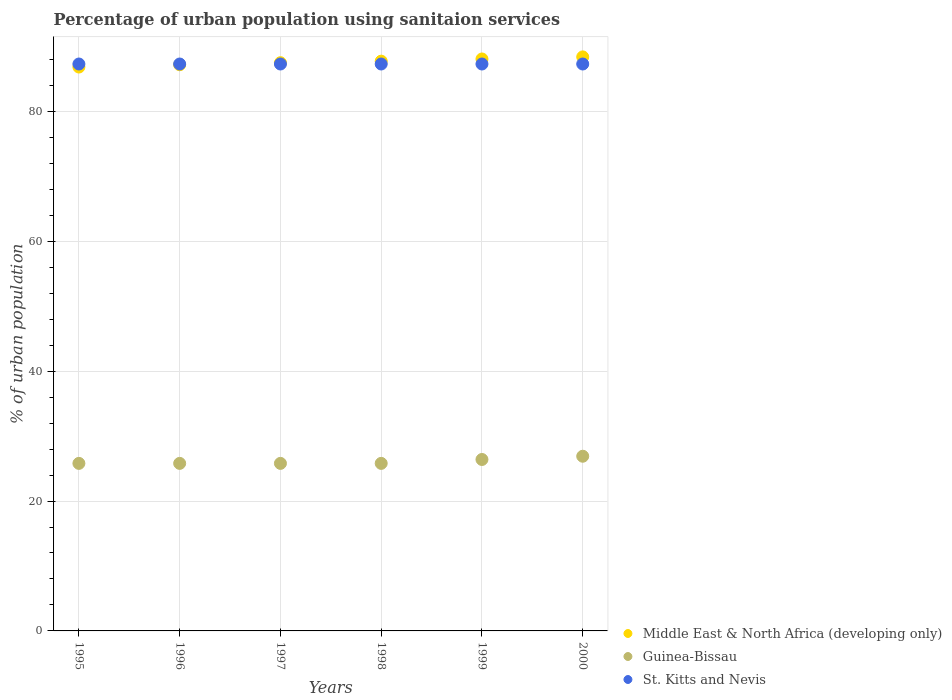Is the number of dotlines equal to the number of legend labels?
Your answer should be compact. Yes. What is the percentage of urban population using sanitaion services in Guinea-Bissau in 1999?
Give a very brief answer. 26.4. Across all years, what is the maximum percentage of urban population using sanitaion services in Guinea-Bissau?
Provide a short and direct response. 26.9. Across all years, what is the minimum percentage of urban population using sanitaion services in Guinea-Bissau?
Your answer should be very brief. 25.8. In which year was the percentage of urban population using sanitaion services in St. Kitts and Nevis minimum?
Ensure brevity in your answer.  1995. What is the total percentage of urban population using sanitaion services in Middle East & North Africa (developing only) in the graph?
Provide a succinct answer. 525.73. What is the difference between the percentage of urban population using sanitaion services in St. Kitts and Nevis in 1997 and that in 1998?
Your response must be concise. 0. What is the difference between the percentage of urban population using sanitaion services in Guinea-Bissau in 1998 and the percentage of urban population using sanitaion services in Middle East & North Africa (developing only) in 1995?
Make the answer very short. -61.03. What is the average percentage of urban population using sanitaion services in St. Kitts and Nevis per year?
Ensure brevity in your answer.  87.3. In the year 1995, what is the difference between the percentage of urban population using sanitaion services in Middle East & North Africa (developing only) and percentage of urban population using sanitaion services in Guinea-Bissau?
Offer a terse response. 61.03. What is the ratio of the percentage of urban population using sanitaion services in Middle East & North Africa (developing only) in 1998 to that in 1999?
Your response must be concise. 1. Is the percentage of urban population using sanitaion services in Guinea-Bissau in 1995 less than that in 2000?
Make the answer very short. Yes. In how many years, is the percentage of urban population using sanitaion services in St. Kitts and Nevis greater than the average percentage of urban population using sanitaion services in St. Kitts and Nevis taken over all years?
Keep it short and to the point. 0. Is the sum of the percentage of urban population using sanitaion services in Guinea-Bissau in 1999 and 2000 greater than the maximum percentage of urban population using sanitaion services in St. Kitts and Nevis across all years?
Your answer should be very brief. No. Is it the case that in every year, the sum of the percentage of urban population using sanitaion services in Middle East & North Africa (developing only) and percentage of urban population using sanitaion services in St. Kitts and Nevis  is greater than the percentage of urban population using sanitaion services in Guinea-Bissau?
Make the answer very short. Yes. How many years are there in the graph?
Your answer should be very brief. 6. What is the difference between two consecutive major ticks on the Y-axis?
Ensure brevity in your answer.  20. Where does the legend appear in the graph?
Provide a short and direct response. Bottom right. How many legend labels are there?
Offer a terse response. 3. How are the legend labels stacked?
Your answer should be compact. Vertical. What is the title of the graph?
Offer a terse response. Percentage of urban population using sanitaion services. What is the label or title of the X-axis?
Give a very brief answer. Years. What is the label or title of the Y-axis?
Provide a short and direct response. % of urban population. What is the % of urban population of Middle East & North Africa (developing only) in 1995?
Your response must be concise. 86.83. What is the % of urban population in Guinea-Bissau in 1995?
Give a very brief answer. 25.8. What is the % of urban population of St. Kitts and Nevis in 1995?
Your answer should be compact. 87.3. What is the % of urban population of Middle East & North Africa (developing only) in 1996?
Give a very brief answer. 87.19. What is the % of urban population in Guinea-Bissau in 1996?
Give a very brief answer. 25.8. What is the % of urban population in St. Kitts and Nevis in 1996?
Your response must be concise. 87.3. What is the % of urban population in Middle East & North Africa (developing only) in 1997?
Keep it short and to the point. 87.5. What is the % of urban population in Guinea-Bissau in 1997?
Provide a succinct answer. 25.8. What is the % of urban population of St. Kitts and Nevis in 1997?
Provide a short and direct response. 87.3. What is the % of urban population in Middle East & North Africa (developing only) in 1998?
Your answer should be compact. 87.74. What is the % of urban population in Guinea-Bissau in 1998?
Your answer should be compact. 25.8. What is the % of urban population in St. Kitts and Nevis in 1998?
Offer a very short reply. 87.3. What is the % of urban population in Middle East & North Africa (developing only) in 1999?
Your answer should be compact. 88.08. What is the % of urban population of Guinea-Bissau in 1999?
Give a very brief answer. 26.4. What is the % of urban population in St. Kitts and Nevis in 1999?
Make the answer very short. 87.3. What is the % of urban population of Middle East & North Africa (developing only) in 2000?
Keep it short and to the point. 88.39. What is the % of urban population of Guinea-Bissau in 2000?
Ensure brevity in your answer.  26.9. What is the % of urban population in St. Kitts and Nevis in 2000?
Provide a succinct answer. 87.3. Across all years, what is the maximum % of urban population in Middle East & North Africa (developing only)?
Make the answer very short. 88.39. Across all years, what is the maximum % of urban population in Guinea-Bissau?
Give a very brief answer. 26.9. Across all years, what is the maximum % of urban population of St. Kitts and Nevis?
Your response must be concise. 87.3. Across all years, what is the minimum % of urban population of Middle East & North Africa (developing only)?
Ensure brevity in your answer.  86.83. Across all years, what is the minimum % of urban population of Guinea-Bissau?
Your answer should be compact. 25.8. Across all years, what is the minimum % of urban population of St. Kitts and Nevis?
Give a very brief answer. 87.3. What is the total % of urban population in Middle East & North Africa (developing only) in the graph?
Provide a short and direct response. 525.73. What is the total % of urban population of Guinea-Bissau in the graph?
Ensure brevity in your answer.  156.5. What is the total % of urban population in St. Kitts and Nevis in the graph?
Offer a very short reply. 523.8. What is the difference between the % of urban population of Middle East & North Africa (developing only) in 1995 and that in 1996?
Keep it short and to the point. -0.35. What is the difference between the % of urban population of Guinea-Bissau in 1995 and that in 1996?
Keep it short and to the point. 0. What is the difference between the % of urban population of Middle East & North Africa (developing only) in 1995 and that in 1997?
Ensure brevity in your answer.  -0.67. What is the difference between the % of urban population of Middle East & North Africa (developing only) in 1995 and that in 1998?
Offer a very short reply. -0.91. What is the difference between the % of urban population of Guinea-Bissau in 1995 and that in 1998?
Give a very brief answer. 0. What is the difference between the % of urban population in Middle East & North Africa (developing only) in 1995 and that in 1999?
Make the answer very short. -1.24. What is the difference between the % of urban population of St. Kitts and Nevis in 1995 and that in 1999?
Your answer should be very brief. 0. What is the difference between the % of urban population of Middle East & North Africa (developing only) in 1995 and that in 2000?
Your answer should be compact. -1.56. What is the difference between the % of urban population in Guinea-Bissau in 1995 and that in 2000?
Provide a succinct answer. -1.1. What is the difference between the % of urban population of Middle East & North Africa (developing only) in 1996 and that in 1997?
Make the answer very short. -0.31. What is the difference between the % of urban population of Guinea-Bissau in 1996 and that in 1997?
Your answer should be compact. 0. What is the difference between the % of urban population of St. Kitts and Nevis in 1996 and that in 1997?
Provide a succinct answer. 0. What is the difference between the % of urban population of Middle East & North Africa (developing only) in 1996 and that in 1998?
Your answer should be compact. -0.55. What is the difference between the % of urban population in Guinea-Bissau in 1996 and that in 1998?
Your answer should be compact. 0. What is the difference between the % of urban population of Middle East & North Africa (developing only) in 1996 and that in 1999?
Your response must be concise. -0.89. What is the difference between the % of urban population of Guinea-Bissau in 1996 and that in 1999?
Ensure brevity in your answer.  -0.6. What is the difference between the % of urban population in Middle East & North Africa (developing only) in 1996 and that in 2000?
Provide a short and direct response. -1.21. What is the difference between the % of urban population in St. Kitts and Nevis in 1996 and that in 2000?
Make the answer very short. 0. What is the difference between the % of urban population in Middle East & North Africa (developing only) in 1997 and that in 1998?
Your answer should be very brief. -0.24. What is the difference between the % of urban population in Guinea-Bissau in 1997 and that in 1998?
Make the answer very short. 0. What is the difference between the % of urban population in St. Kitts and Nevis in 1997 and that in 1998?
Give a very brief answer. 0. What is the difference between the % of urban population of Middle East & North Africa (developing only) in 1997 and that in 1999?
Offer a very short reply. -0.57. What is the difference between the % of urban population of Middle East & North Africa (developing only) in 1997 and that in 2000?
Your response must be concise. -0.89. What is the difference between the % of urban population of Middle East & North Africa (developing only) in 1998 and that in 1999?
Offer a terse response. -0.34. What is the difference between the % of urban population in Guinea-Bissau in 1998 and that in 1999?
Your answer should be compact. -0.6. What is the difference between the % of urban population of Middle East & North Africa (developing only) in 1998 and that in 2000?
Offer a very short reply. -0.66. What is the difference between the % of urban population in Guinea-Bissau in 1998 and that in 2000?
Offer a terse response. -1.1. What is the difference between the % of urban population in St. Kitts and Nevis in 1998 and that in 2000?
Give a very brief answer. 0. What is the difference between the % of urban population in Middle East & North Africa (developing only) in 1999 and that in 2000?
Your response must be concise. -0.32. What is the difference between the % of urban population in Guinea-Bissau in 1999 and that in 2000?
Make the answer very short. -0.5. What is the difference between the % of urban population of St. Kitts and Nevis in 1999 and that in 2000?
Offer a very short reply. 0. What is the difference between the % of urban population in Middle East & North Africa (developing only) in 1995 and the % of urban population in Guinea-Bissau in 1996?
Give a very brief answer. 61.03. What is the difference between the % of urban population in Middle East & North Africa (developing only) in 1995 and the % of urban population in St. Kitts and Nevis in 1996?
Your response must be concise. -0.47. What is the difference between the % of urban population in Guinea-Bissau in 1995 and the % of urban population in St. Kitts and Nevis in 1996?
Provide a short and direct response. -61.5. What is the difference between the % of urban population of Middle East & North Africa (developing only) in 1995 and the % of urban population of Guinea-Bissau in 1997?
Your response must be concise. 61.03. What is the difference between the % of urban population in Middle East & North Africa (developing only) in 1995 and the % of urban population in St. Kitts and Nevis in 1997?
Ensure brevity in your answer.  -0.47. What is the difference between the % of urban population of Guinea-Bissau in 1995 and the % of urban population of St. Kitts and Nevis in 1997?
Offer a very short reply. -61.5. What is the difference between the % of urban population of Middle East & North Africa (developing only) in 1995 and the % of urban population of Guinea-Bissau in 1998?
Keep it short and to the point. 61.03. What is the difference between the % of urban population of Middle East & North Africa (developing only) in 1995 and the % of urban population of St. Kitts and Nevis in 1998?
Offer a terse response. -0.47. What is the difference between the % of urban population of Guinea-Bissau in 1995 and the % of urban population of St. Kitts and Nevis in 1998?
Ensure brevity in your answer.  -61.5. What is the difference between the % of urban population of Middle East & North Africa (developing only) in 1995 and the % of urban population of Guinea-Bissau in 1999?
Offer a terse response. 60.43. What is the difference between the % of urban population in Middle East & North Africa (developing only) in 1995 and the % of urban population in St. Kitts and Nevis in 1999?
Give a very brief answer. -0.47. What is the difference between the % of urban population in Guinea-Bissau in 1995 and the % of urban population in St. Kitts and Nevis in 1999?
Keep it short and to the point. -61.5. What is the difference between the % of urban population in Middle East & North Africa (developing only) in 1995 and the % of urban population in Guinea-Bissau in 2000?
Keep it short and to the point. 59.93. What is the difference between the % of urban population of Middle East & North Africa (developing only) in 1995 and the % of urban population of St. Kitts and Nevis in 2000?
Your answer should be compact. -0.47. What is the difference between the % of urban population in Guinea-Bissau in 1995 and the % of urban population in St. Kitts and Nevis in 2000?
Keep it short and to the point. -61.5. What is the difference between the % of urban population of Middle East & North Africa (developing only) in 1996 and the % of urban population of Guinea-Bissau in 1997?
Give a very brief answer. 61.39. What is the difference between the % of urban population in Middle East & North Africa (developing only) in 1996 and the % of urban population in St. Kitts and Nevis in 1997?
Your answer should be compact. -0.11. What is the difference between the % of urban population of Guinea-Bissau in 1996 and the % of urban population of St. Kitts and Nevis in 1997?
Offer a terse response. -61.5. What is the difference between the % of urban population of Middle East & North Africa (developing only) in 1996 and the % of urban population of Guinea-Bissau in 1998?
Give a very brief answer. 61.39. What is the difference between the % of urban population in Middle East & North Africa (developing only) in 1996 and the % of urban population in St. Kitts and Nevis in 1998?
Keep it short and to the point. -0.11. What is the difference between the % of urban population of Guinea-Bissau in 1996 and the % of urban population of St. Kitts and Nevis in 1998?
Provide a short and direct response. -61.5. What is the difference between the % of urban population of Middle East & North Africa (developing only) in 1996 and the % of urban population of Guinea-Bissau in 1999?
Offer a very short reply. 60.79. What is the difference between the % of urban population of Middle East & North Africa (developing only) in 1996 and the % of urban population of St. Kitts and Nevis in 1999?
Offer a very short reply. -0.11. What is the difference between the % of urban population of Guinea-Bissau in 1996 and the % of urban population of St. Kitts and Nevis in 1999?
Provide a short and direct response. -61.5. What is the difference between the % of urban population in Middle East & North Africa (developing only) in 1996 and the % of urban population in Guinea-Bissau in 2000?
Provide a succinct answer. 60.29. What is the difference between the % of urban population in Middle East & North Africa (developing only) in 1996 and the % of urban population in St. Kitts and Nevis in 2000?
Your answer should be compact. -0.11. What is the difference between the % of urban population of Guinea-Bissau in 1996 and the % of urban population of St. Kitts and Nevis in 2000?
Your answer should be compact. -61.5. What is the difference between the % of urban population of Middle East & North Africa (developing only) in 1997 and the % of urban population of Guinea-Bissau in 1998?
Provide a short and direct response. 61.7. What is the difference between the % of urban population of Middle East & North Africa (developing only) in 1997 and the % of urban population of St. Kitts and Nevis in 1998?
Offer a very short reply. 0.2. What is the difference between the % of urban population of Guinea-Bissau in 1997 and the % of urban population of St. Kitts and Nevis in 1998?
Your answer should be compact. -61.5. What is the difference between the % of urban population in Middle East & North Africa (developing only) in 1997 and the % of urban population in Guinea-Bissau in 1999?
Provide a succinct answer. 61.1. What is the difference between the % of urban population in Middle East & North Africa (developing only) in 1997 and the % of urban population in St. Kitts and Nevis in 1999?
Provide a succinct answer. 0.2. What is the difference between the % of urban population of Guinea-Bissau in 1997 and the % of urban population of St. Kitts and Nevis in 1999?
Provide a succinct answer. -61.5. What is the difference between the % of urban population of Middle East & North Africa (developing only) in 1997 and the % of urban population of Guinea-Bissau in 2000?
Provide a short and direct response. 60.6. What is the difference between the % of urban population of Middle East & North Africa (developing only) in 1997 and the % of urban population of St. Kitts and Nevis in 2000?
Give a very brief answer. 0.2. What is the difference between the % of urban population of Guinea-Bissau in 1997 and the % of urban population of St. Kitts and Nevis in 2000?
Provide a succinct answer. -61.5. What is the difference between the % of urban population in Middle East & North Africa (developing only) in 1998 and the % of urban population in Guinea-Bissau in 1999?
Keep it short and to the point. 61.34. What is the difference between the % of urban population of Middle East & North Africa (developing only) in 1998 and the % of urban population of St. Kitts and Nevis in 1999?
Offer a very short reply. 0.44. What is the difference between the % of urban population in Guinea-Bissau in 1998 and the % of urban population in St. Kitts and Nevis in 1999?
Provide a short and direct response. -61.5. What is the difference between the % of urban population of Middle East & North Africa (developing only) in 1998 and the % of urban population of Guinea-Bissau in 2000?
Provide a short and direct response. 60.84. What is the difference between the % of urban population of Middle East & North Africa (developing only) in 1998 and the % of urban population of St. Kitts and Nevis in 2000?
Provide a succinct answer. 0.44. What is the difference between the % of urban population of Guinea-Bissau in 1998 and the % of urban population of St. Kitts and Nevis in 2000?
Your answer should be compact. -61.5. What is the difference between the % of urban population of Middle East & North Africa (developing only) in 1999 and the % of urban population of Guinea-Bissau in 2000?
Your response must be concise. 61.18. What is the difference between the % of urban population of Middle East & North Africa (developing only) in 1999 and the % of urban population of St. Kitts and Nevis in 2000?
Provide a succinct answer. 0.78. What is the difference between the % of urban population in Guinea-Bissau in 1999 and the % of urban population in St. Kitts and Nevis in 2000?
Your response must be concise. -60.9. What is the average % of urban population in Middle East & North Africa (developing only) per year?
Give a very brief answer. 87.62. What is the average % of urban population of Guinea-Bissau per year?
Make the answer very short. 26.08. What is the average % of urban population in St. Kitts and Nevis per year?
Make the answer very short. 87.3. In the year 1995, what is the difference between the % of urban population of Middle East & North Africa (developing only) and % of urban population of Guinea-Bissau?
Your answer should be very brief. 61.03. In the year 1995, what is the difference between the % of urban population of Middle East & North Africa (developing only) and % of urban population of St. Kitts and Nevis?
Ensure brevity in your answer.  -0.47. In the year 1995, what is the difference between the % of urban population of Guinea-Bissau and % of urban population of St. Kitts and Nevis?
Provide a short and direct response. -61.5. In the year 1996, what is the difference between the % of urban population in Middle East & North Africa (developing only) and % of urban population in Guinea-Bissau?
Your response must be concise. 61.39. In the year 1996, what is the difference between the % of urban population of Middle East & North Africa (developing only) and % of urban population of St. Kitts and Nevis?
Keep it short and to the point. -0.11. In the year 1996, what is the difference between the % of urban population of Guinea-Bissau and % of urban population of St. Kitts and Nevis?
Make the answer very short. -61.5. In the year 1997, what is the difference between the % of urban population of Middle East & North Africa (developing only) and % of urban population of Guinea-Bissau?
Offer a terse response. 61.7. In the year 1997, what is the difference between the % of urban population in Middle East & North Africa (developing only) and % of urban population in St. Kitts and Nevis?
Keep it short and to the point. 0.2. In the year 1997, what is the difference between the % of urban population of Guinea-Bissau and % of urban population of St. Kitts and Nevis?
Ensure brevity in your answer.  -61.5. In the year 1998, what is the difference between the % of urban population of Middle East & North Africa (developing only) and % of urban population of Guinea-Bissau?
Keep it short and to the point. 61.94. In the year 1998, what is the difference between the % of urban population of Middle East & North Africa (developing only) and % of urban population of St. Kitts and Nevis?
Keep it short and to the point. 0.44. In the year 1998, what is the difference between the % of urban population of Guinea-Bissau and % of urban population of St. Kitts and Nevis?
Offer a terse response. -61.5. In the year 1999, what is the difference between the % of urban population in Middle East & North Africa (developing only) and % of urban population in Guinea-Bissau?
Provide a succinct answer. 61.68. In the year 1999, what is the difference between the % of urban population of Middle East & North Africa (developing only) and % of urban population of St. Kitts and Nevis?
Provide a short and direct response. 0.78. In the year 1999, what is the difference between the % of urban population in Guinea-Bissau and % of urban population in St. Kitts and Nevis?
Make the answer very short. -60.9. In the year 2000, what is the difference between the % of urban population of Middle East & North Africa (developing only) and % of urban population of Guinea-Bissau?
Provide a succinct answer. 61.49. In the year 2000, what is the difference between the % of urban population in Middle East & North Africa (developing only) and % of urban population in St. Kitts and Nevis?
Make the answer very short. 1.09. In the year 2000, what is the difference between the % of urban population in Guinea-Bissau and % of urban population in St. Kitts and Nevis?
Provide a short and direct response. -60.4. What is the ratio of the % of urban population in Middle East & North Africa (developing only) in 1995 to that in 1996?
Your answer should be compact. 1. What is the ratio of the % of urban population of Guinea-Bissau in 1995 to that in 1996?
Offer a very short reply. 1. What is the ratio of the % of urban population in St. Kitts and Nevis in 1995 to that in 1997?
Make the answer very short. 1. What is the ratio of the % of urban population of Guinea-Bissau in 1995 to that in 1998?
Offer a terse response. 1. What is the ratio of the % of urban population in Middle East & North Africa (developing only) in 1995 to that in 1999?
Give a very brief answer. 0.99. What is the ratio of the % of urban population of Guinea-Bissau in 1995 to that in 1999?
Your answer should be compact. 0.98. What is the ratio of the % of urban population of Middle East & North Africa (developing only) in 1995 to that in 2000?
Your answer should be very brief. 0.98. What is the ratio of the % of urban population in Guinea-Bissau in 1995 to that in 2000?
Ensure brevity in your answer.  0.96. What is the ratio of the % of urban population of Guinea-Bissau in 1996 to that in 1997?
Give a very brief answer. 1. What is the ratio of the % of urban population of St. Kitts and Nevis in 1996 to that in 1997?
Keep it short and to the point. 1. What is the ratio of the % of urban population of Middle East & North Africa (developing only) in 1996 to that in 1998?
Your response must be concise. 0.99. What is the ratio of the % of urban population of Guinea-Bissau in 1996 to that in 1998?
Give a very brief answer. 1. What is the ratio of the % of urban population of Middle East & North Africa (developing only) in 1996 to that in 1999?
Provide a short and direct response. 0.99. What is the ratio of the % of urban population in Guinea-Bissau in 1996 to that in 1999?
Provide a succinct answer. 0.98. What is the ratio of the % of urban population of St. Kitts and Nevis in 1996 to that in 1999?
Provide a short and direct response. 1. What is the ratio of the % of urban population of Middle East & North Africa (developing only) in 1996 to that in 2000?
Make the answer very short. 0.99. What is the ratio of the % of urban population of Guinea-Bissau in 1996 to that in 2000?
Make the answer very short. 0.96. What is the ratio of the % of urban population of St. Kitts and Nevis in 1997 to that in 1998?
Offer a very short reply. 1. What is the ratio of the % of urban population of Guinea-Bissau in 1997 to that in 1999?
Your answer should be compact. 0.98. What is the ratio of the % of urban population in St. Kitts and Nevis in 1997 to that in 1999?
Keep it short and to the point. 1. What is the ratio of the % of urban population in Guinea-Bissau in 1997 to that in 2000?
Your response must be concise. 0.96. What is the ratio of the % of urban population of Middle East & North Africa (developing only) in 1998 to that in 1999?
Make the answer very short. 1. What is the ratio of the % of urban population in Guinea-Bissau in 1998 to that in 1999?
Offer a terse response. 0.98. What is the ratio of the % of urban population in St. Kitts and Nevis in 1998 to that in 1999?
Your answer should be compact. 1. What is the ratio of the % of urban population in Middle East & North Africa (developing only) in 1998 to that in 2000?
Make the answer very short. 0.99. What is the ratio of the % of urban population in Guinea-Bissau in 1998 to that in 2000?
Your answer should be compact. 0.96. What is the ratio of the % of urban population of Middle East & North Africa (developing only) in 1999 to that in 2000?
Your answer should be compact. 1. What is the ratio of the % of urban population in Guinea-Bissau in 1999 to that in 2000?
Your answer should be very brief. 0.98. What is the difference between the highest and the second highest % of urban population of Middle East & North Africa (developing only)?
Keep it short and to the point. 0.32. What is the difference between the highest and the second highest % of urban population of Guinea-Bissau?
Keep it short and to the point. 0.5. What is the difference between the highest and the second highest % of urban population in St. Kitts and Nevis?
Offer a very short reply. 0. What is the difference between the highest and the lowest % of urban population in Middle East & North Africa (developing only)?
Keep it short and to the point. 1.56. What is the difference between the highest and the lowest % of urban population in St. Kitts and Nevis?
Keep it short and to the point. 0. 